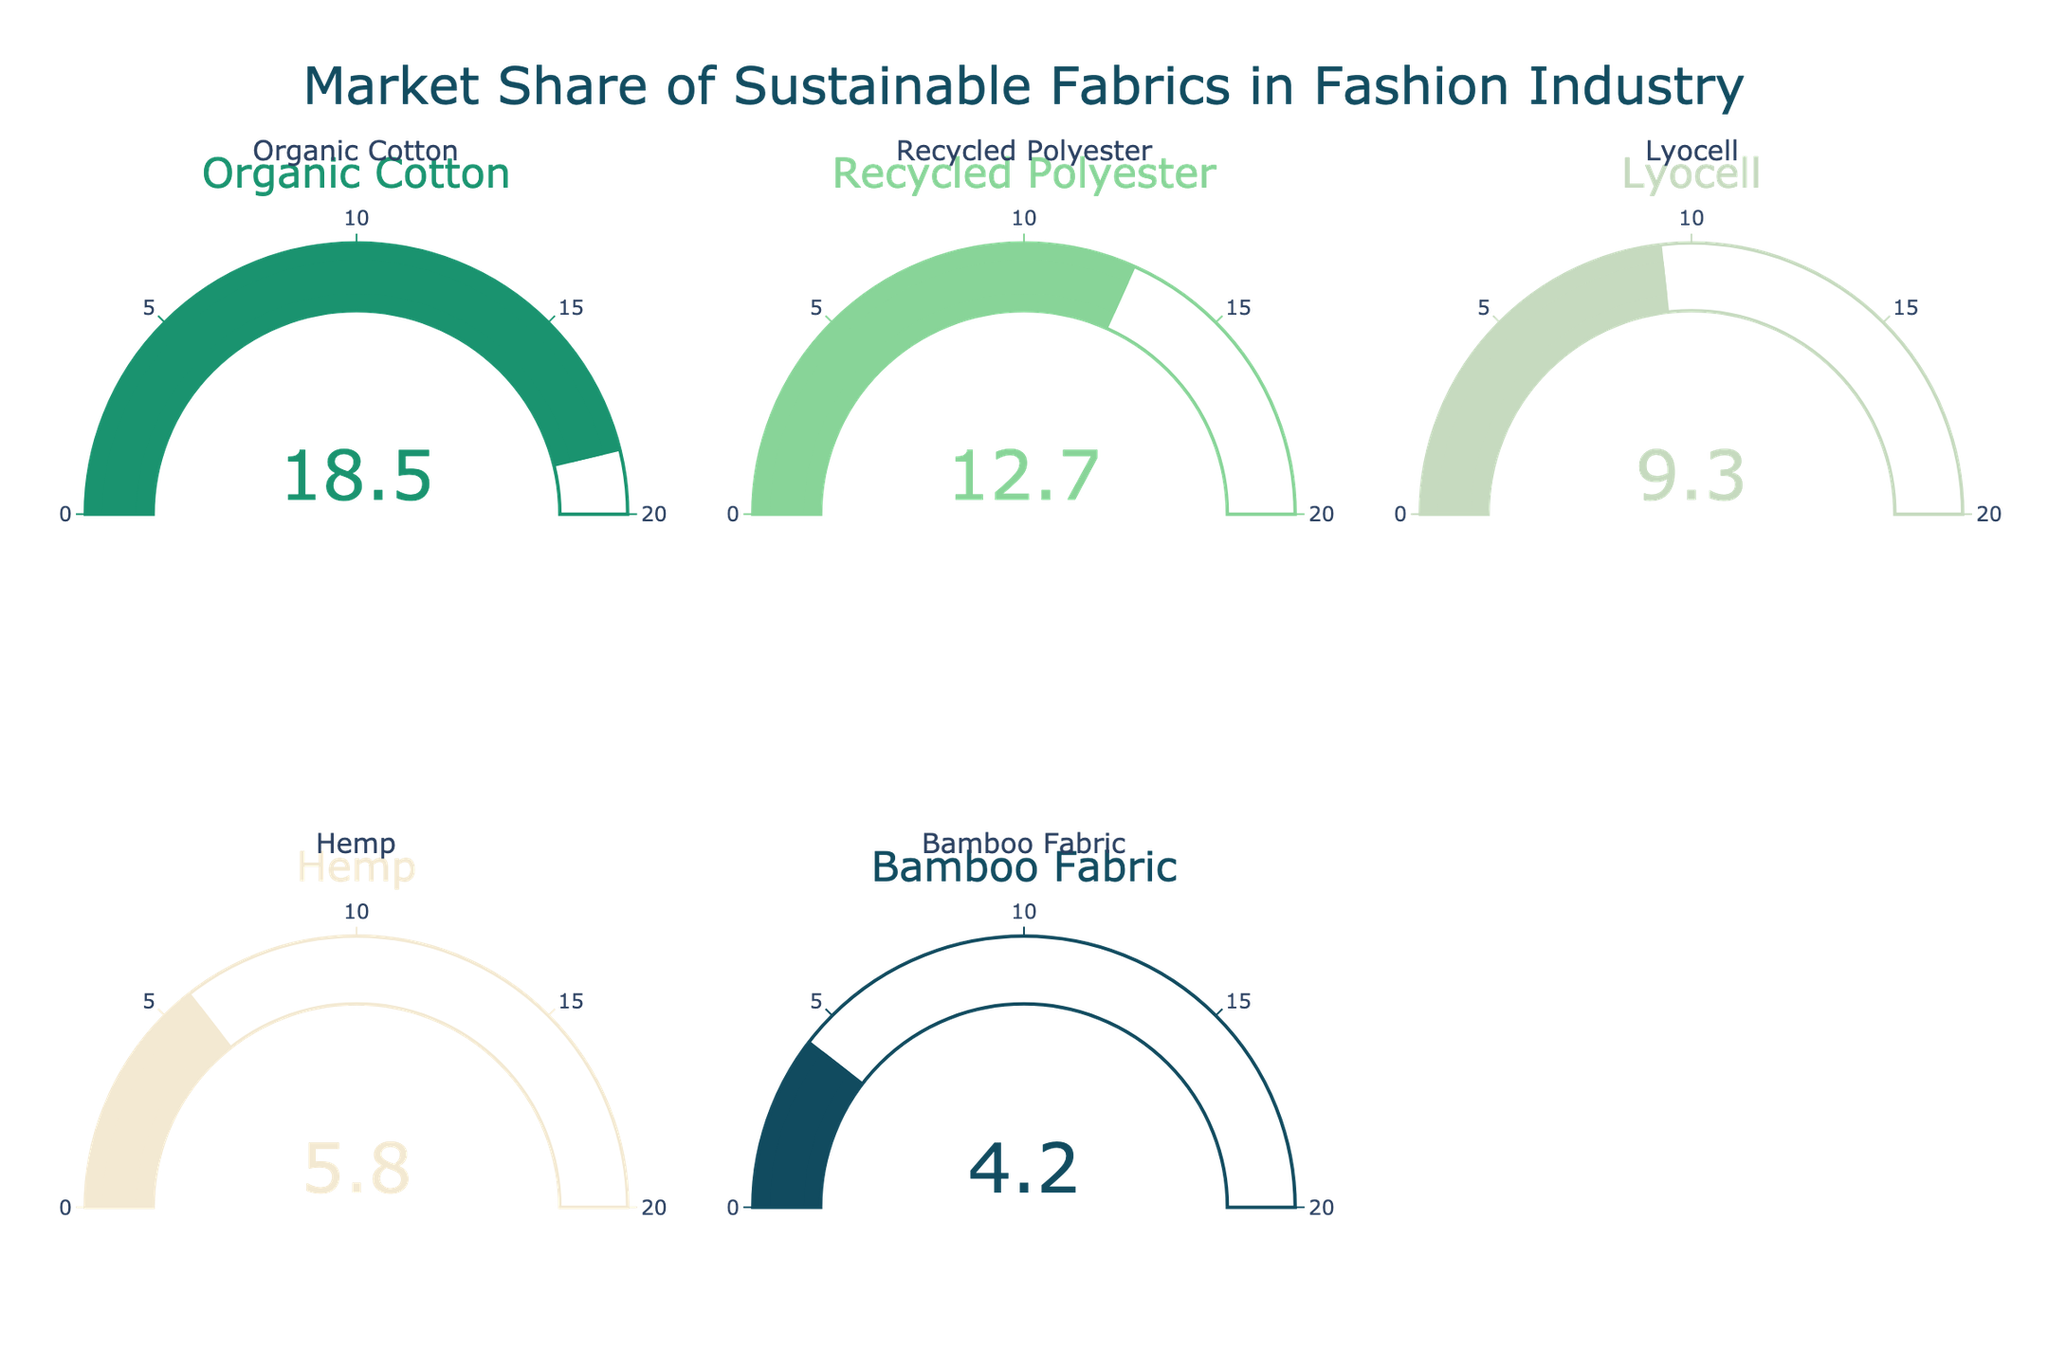What's the title of the chart? The title is located at the top of the chart.
Answer: Market Share of Sustainable Fabrics in Fashion Industry How many categories of sustainable fabrics are displayed in the chart? Count the number of gauge charts in the figure.
Answer: Five Which sustainable fabric has the highest market share? Compare the numbers on each gauge and identify the highest one.
Answer: Organic Cotton What is the market share of Recycled Polyester? Look at the number displayed on the gauge for Recycled Polyester.
Answer: 12.7 How much more market share does Organic Cotton have compared to Hemp? Subtract the market share of Hemp from that of Organic Cotton (18.5 - 5.8).
Answer: 12.7 What is the total market share of all the sustainable fabrics combined? Sum the market shares of all categories (18.5 + 12.7 + 9.3 + 5.8 + 4.2).
Answer: 50.5 Is the market share of Bamboo Fabric greater than that of Lyocell? Compare the numbers on the gauges for Bamboo Fabric and Lyocell.
Answer: No What is the average market share of the five displayed fabrics? Sum the market shares and divide by the number of categories (50.5 / 5).
Answer: 10.1 Which two fabrics, when combined, have the same market share as Organic Cotton? Find the combination of two fabrics whose shares add up to 18.5. Recycled Polyester (12.7) + Bamboo Fabric (4.2)
Answer: Recycled Polyester and Bamboo Fabric Among the displayed fabrics, which one has a market share closest to 10%? Compare the displayed market shares and find the one closest to 10.
Answer: Lyocell 